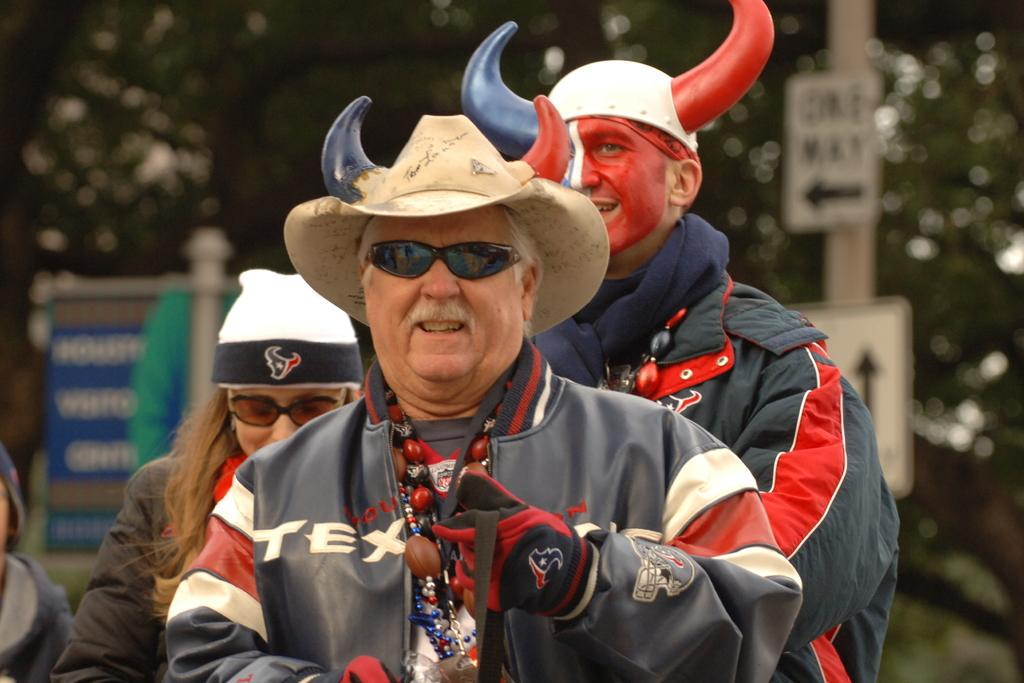How many people are in the group shown in the image? There is a group of people in the image, but the exact number cannot be determined from the provided facts. What accessories are some people in the group wearing? Some people in the group are wearing caps and spectacles. What can be seen in the background of the image? There are sign boards and a pole in the background of the image. What is the name of the brick building in the image? There is no brick building present in the image. Is there a stage visible in the image? There is no stage visible in the image. 